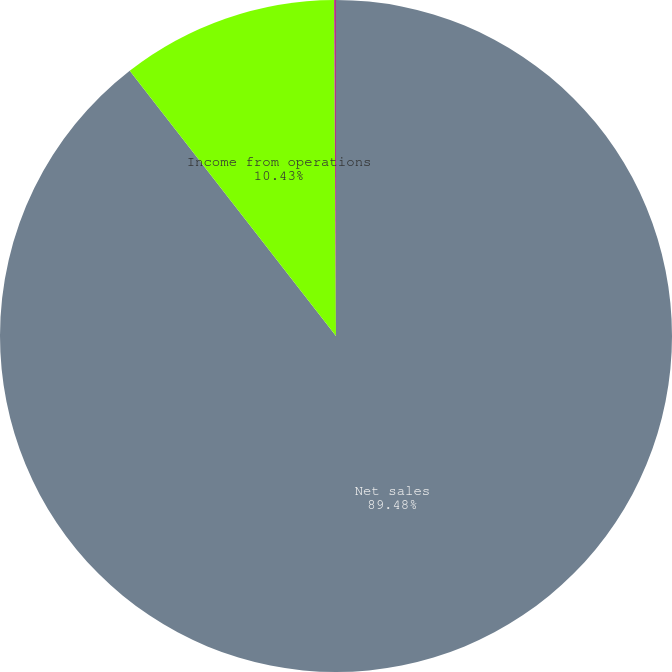Convert chart to OTSL. <chart><loc_0><loc_0><loc_500><loc_500><pie_chart><fcel>Net sales<fcel>Income from operations<fcel>Operating margin<nl><fcel>89.48%<fcel>10.43%<fcel>0.09%<nl></chart> 